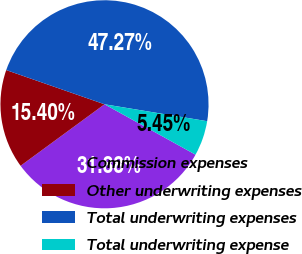<chart> <loc_0><loc_0><loc_500><loc_500><pie_chart><fcel>Commission expenses<fcel>Other underwriting expenses<fcel>Total underwriting expenses<fcel>Total underwriting expense<nl><fcel>31.88%<fcel>15.4%<fcel>47.27%<fcel>5.45%<nl></chart> 